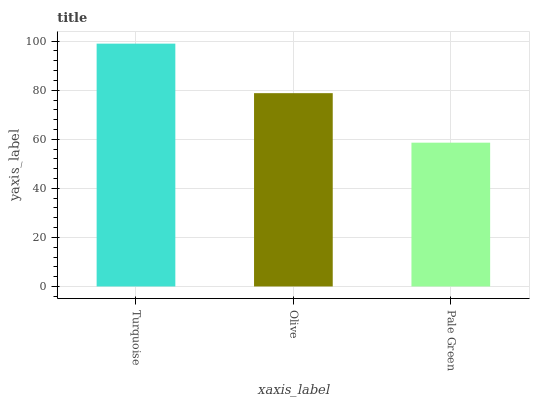Is Pale Green the minimum?
Answer yes or no. Yes. Is Turquoise the maximum?
Answer yes or no. Yes. Is Olive the minimum?
Answer yes or no. No. Is Olive the maximum?
Answer yes or no. No. Is Turquoise greater than Olive?
Answer yes or no. Yes. Is Olive less than Turquoise?
Answer yes or no. Yes. Is Olive greater than Turquoise?
Answer yes or no. No. Is Turquoise less than Olive?
Answer yes or no. No. Is Olive the high median?
Answer yes or no. Yes. Is Olive the low median?
Answer yes or no. Yes. Is Turquoise the high median?
Answer yes or no. No. Is Pale Green the low median?
Answer yes or no. No. 